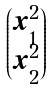<formula> <loc_0><loc_0><loc_500><loc_500>\begin{pmatrix} x _ { 1 } ^ { 2 } \\ x _ { 2 } ^ { 2 } \end{pmatrix}</formula> 